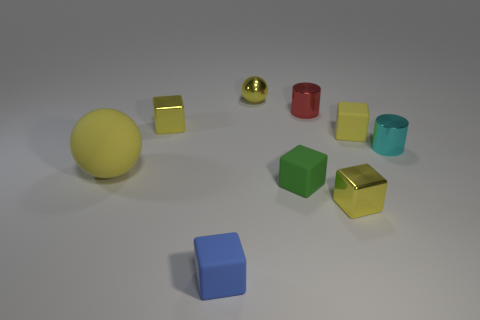Are there any other things that have the same size as the yellow matte ball?
Offer a terse response. No. What shape is the other rubber thing that is the same color as the large rubber thing?
Your answer should be compact. Cube. Is the color of the small sphere the same as the big sphere?
Give a very brief answer. Yes. How many matte objects are behind the blue cube and right of the large matte ball?
Offer a terse response. 2. There is a small yellow metal thing in front of the shiny block that is on the left side of the blue thing; what number of metal balls are in front of it?
Provide a succinct answer. 0. The other metallic ball that is the same color as the big sphere is what size?
Your answer should be very brief. Small. The green thing has what shape?
Offer a terse response. Cube. What number of yellow cubes have the same material as the red object?
Give a very brief answer. 2. What is the color of the sphere that is the same material as the tiny blue object?
Offer a very short reply. Yellow. Do the cyan thing and the yellow sphere in front of the cyan cylinder have the same size?
Make the answer very short. No. 